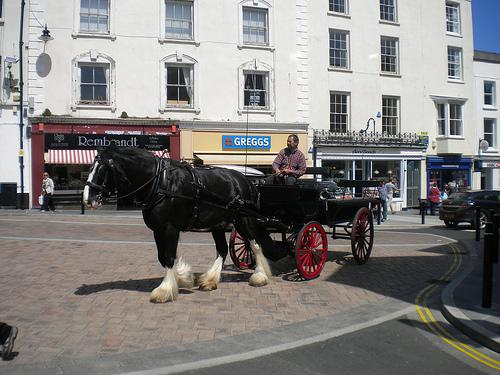Question: what are the names of the stores in the background?
Choices:
A. Marshall's.
B. Greggs and Rembrandt.
C. Old Navy.
D. Payless shoes.
Answer with the letter. Answer: B Question: what color is the Greggs sign?
Choices:
A. Green.
B. Red.
C. Yellow.
D. Blue.
Answer with the letter. Answer: D 